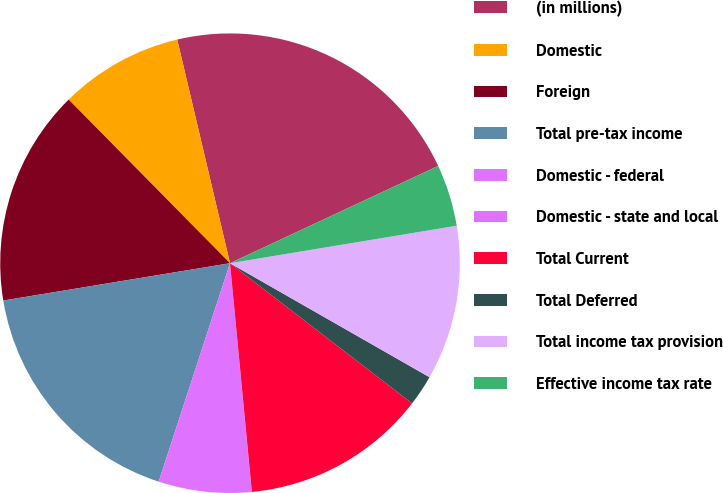<chart> <loc_0><loc_0><loc_500><loc_500><pie_chart><fcel>(in millions)<fcel>Domestic<fcel>Foreign<fcel>Total pre-tax income<fcel>Domestic - federal<fcel>Domestic - state and local<fcel>Total Current<fcel>Total Deferred<fcel>Total income tax provision<fcel>Effective income tax rate<nl><fcel>21.73%<fcel>8.7%<fcel>15.21%<fcel>17.38%<fcel>6.53%<fcel>0.01%<fcel>13.04%<fcel>2.18%<fcel>10.87%<fcel>4.35%<nl></chart> 